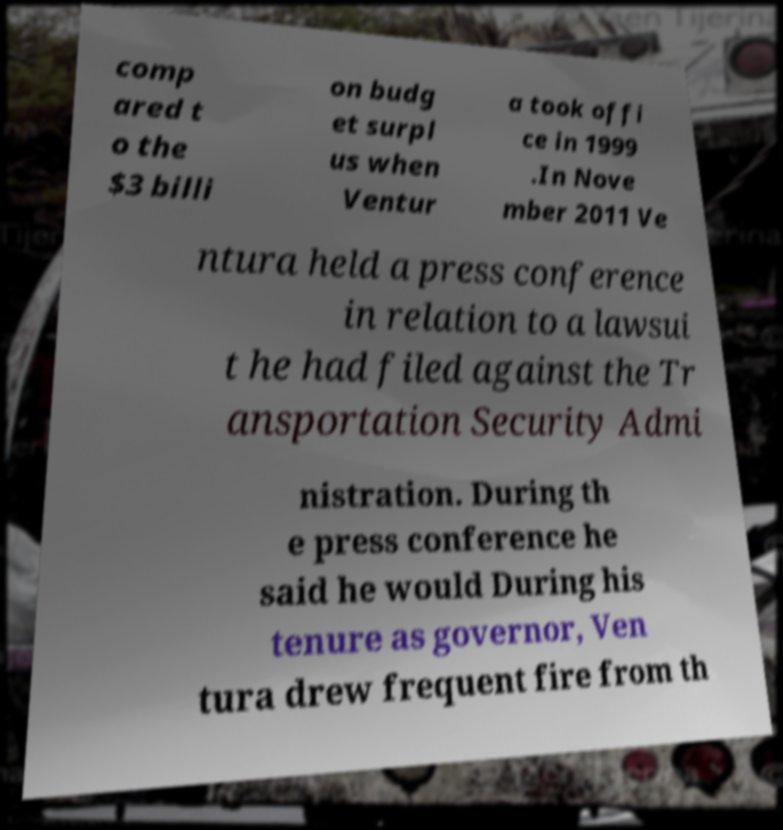There's text embedded in this image that I need extracted. Can you transcribe it verbatim? comp ared t o the $3 billi on budg et surpl us when Ventur a took offi ce in 1999 .In Nove mber 2011 Ve ntura held a press conference in relation to a lawsui t he had filed against the Tr ansportation Security Admi nistration. During th e press conference he said he would During his tenure as governor, Ven tura drew frequent fire from th 